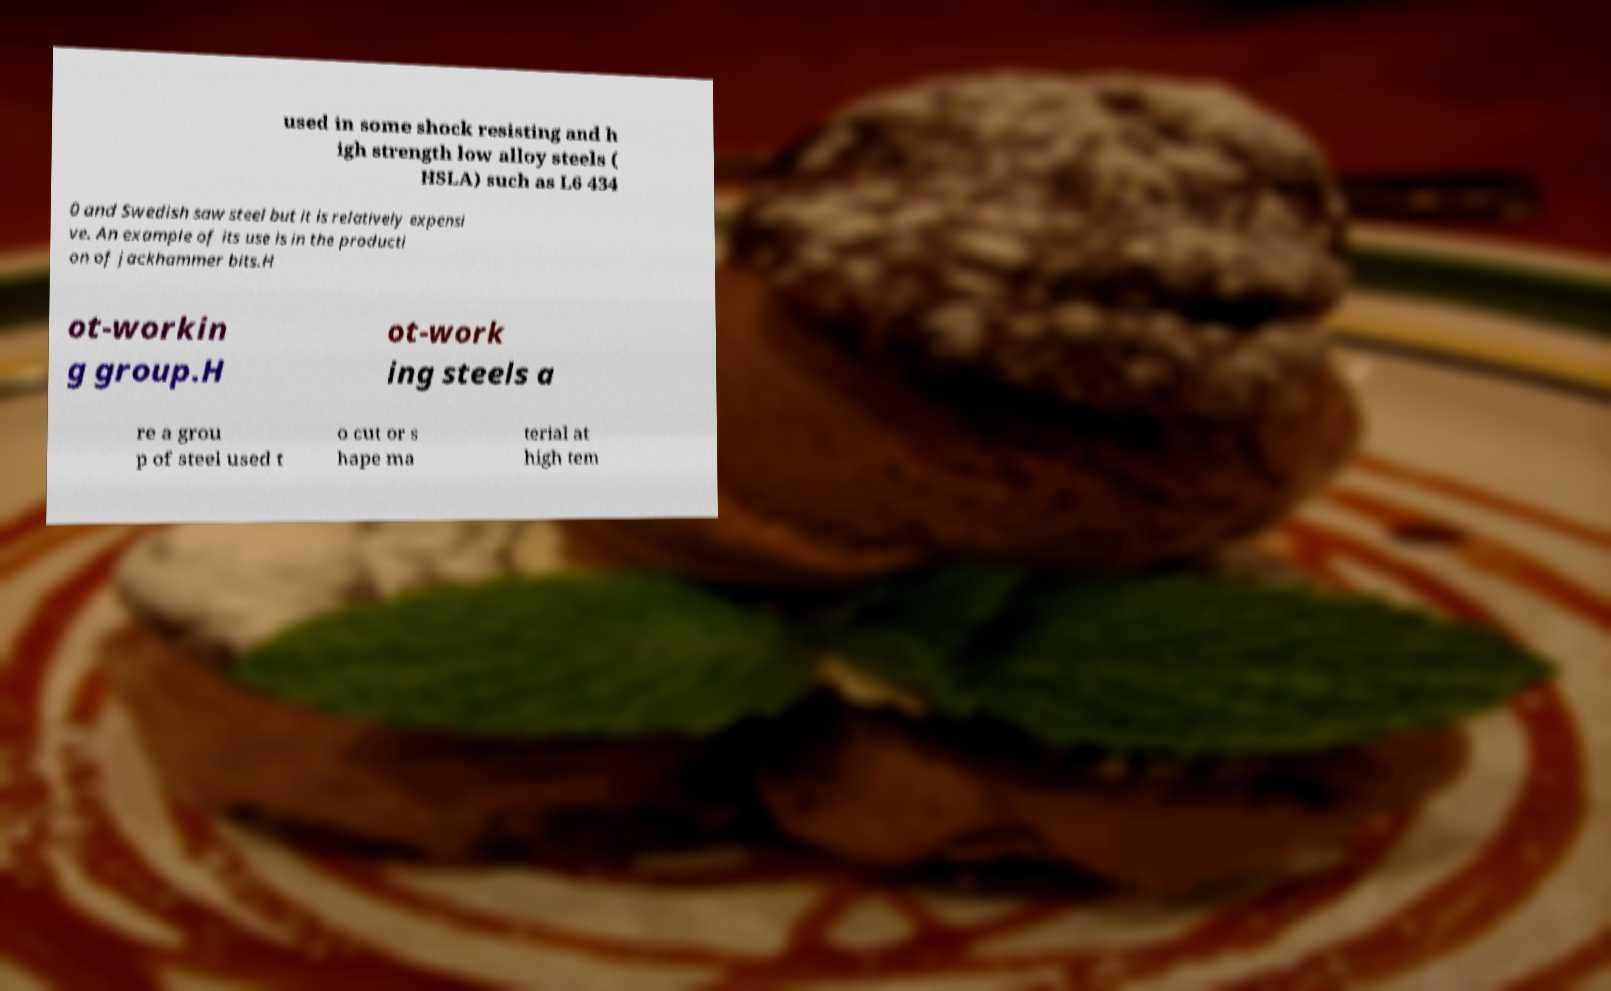For documentation purposes, I need the text within this image transcribed. Could you provide that? used in some shock resisting and h igh strength low alloy steels ( HSLA) such as L6 434 0 and Swedish saw steel but it is relatively expensi ve. An example of its use is in the producti on of jackhammer bits.H ot-workin g group.H ot-work ing steels a re a grou p of steel used t o cut or s hape ma terial at high tem 